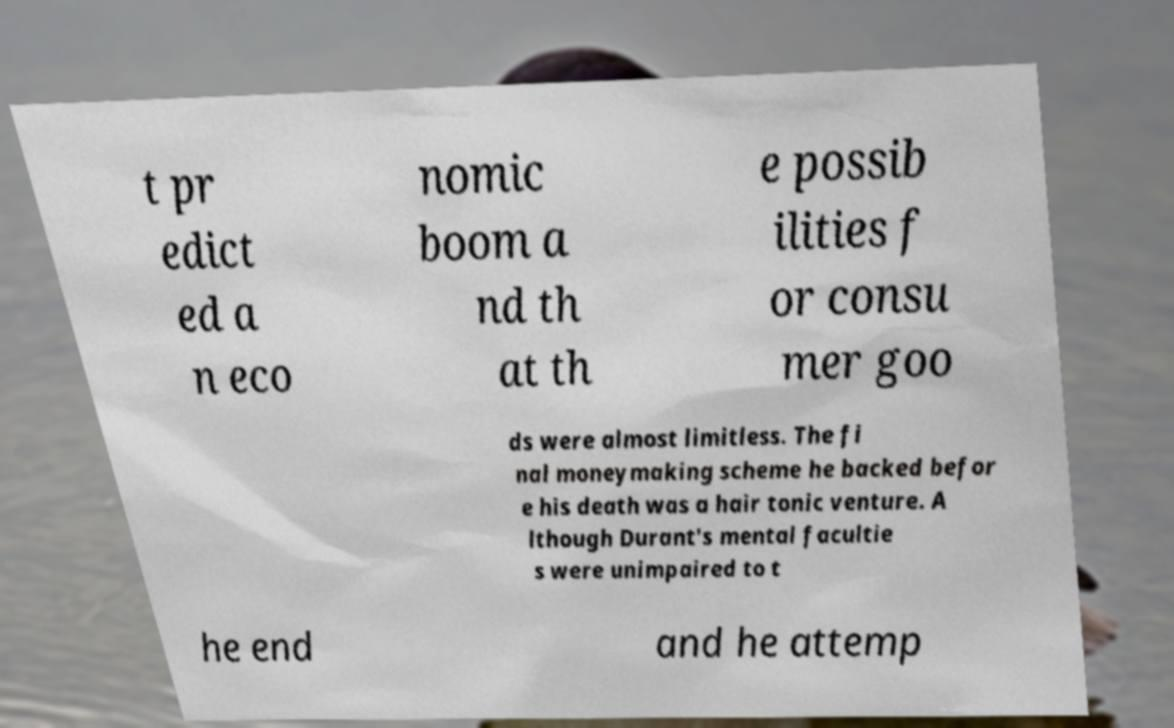What messages or text are displayed in this image? I need them in a readable, typed format. t pr edict ed a n eco nomic boom a nd th at th e possib ilities f or consu mer goo ds were almost limitless. The fi nal moneymaking scheme he backed befor e his death was a hair tonic venture. A lthough Durant's mental facultie s were unimpaired to t he end and he attemp 